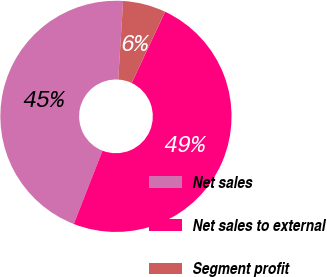Convert chart. <chart><loc_0><loc_0><loc_500><loc_500><pie_chart><fcel>Net sales<fcel>Net sales to external<fcel>Segment profit<nl><fcel>45.05%<fcel>48.95%<fcel>6.01%<nl></chart> 